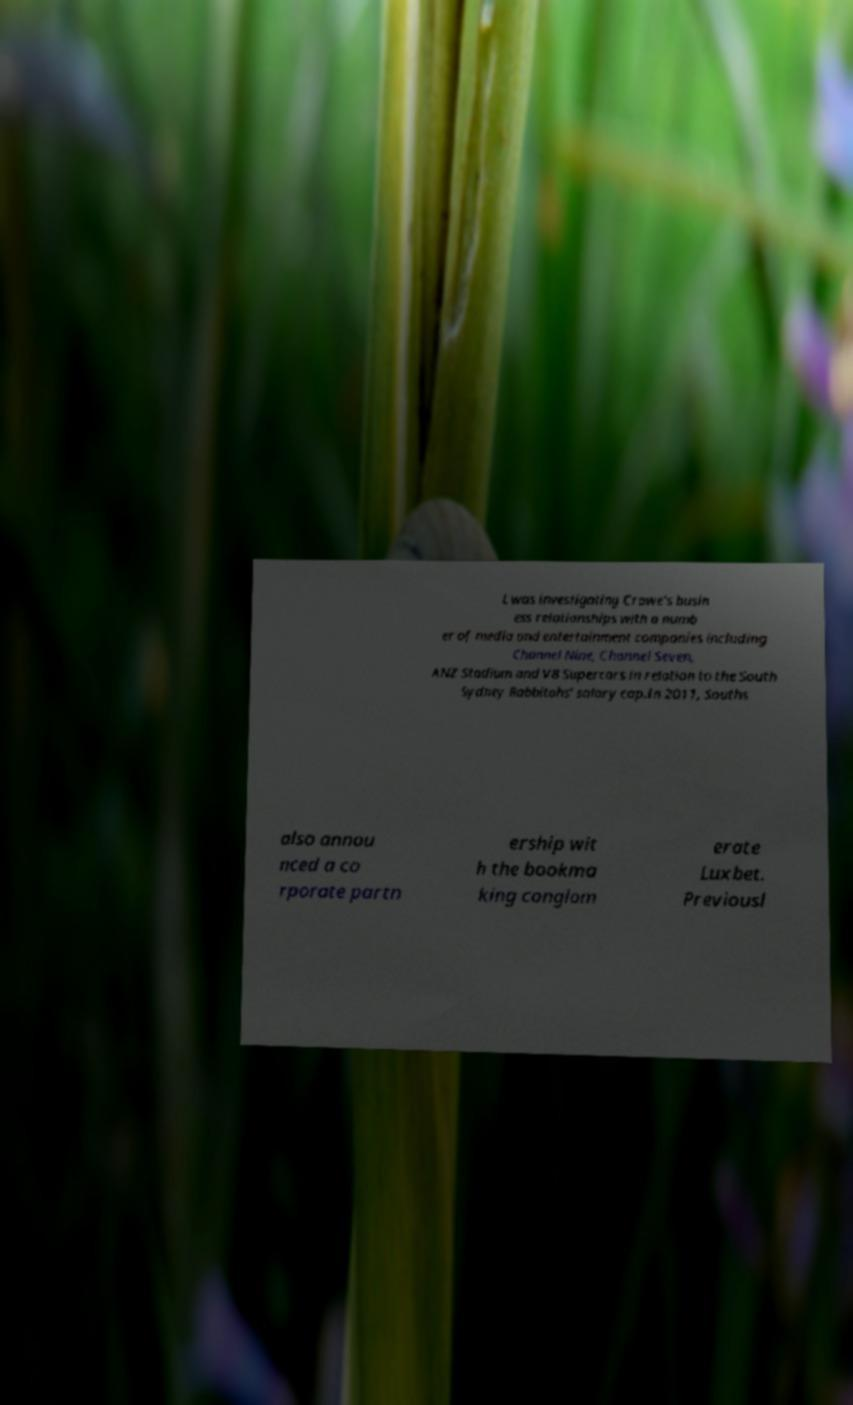Please identify and transcribe the text found in this image. L was investigating Crowe's busin ess relationships with a numb er of media and entertainment companies including Channel Nine, Channel Seven, ANZ Stadium and V8 Supercars in relation to the South Sydney Rabbitohs' salary cap.In 2011, Souths also annou nced a co rporate partn ership wit h the bookma king conglom erate Luxbet. Previousl 